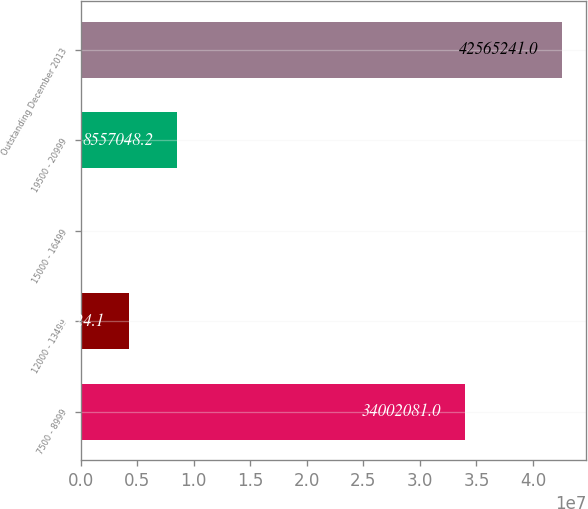Convert chart. <chart><loc_0><loc_0><loc_500><loc_500><bar_chart><fcel>7500 - 8999<fcel>12000 - 13499<fcel>15000 - 16499<fcel>19500 - 20999<fcel>Outstanding December 2013<nl><fcel>3.40021e+07<fcel>4.30602e+06<fcel>55000<fcel>8.55705e+06<fcel>4.25652e+07<nl></chart> 